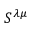Convert formula to latex. <formula><loc_0><loc_0><loc_500><loc_500>S ^ { \lambda \mu }</formula> 